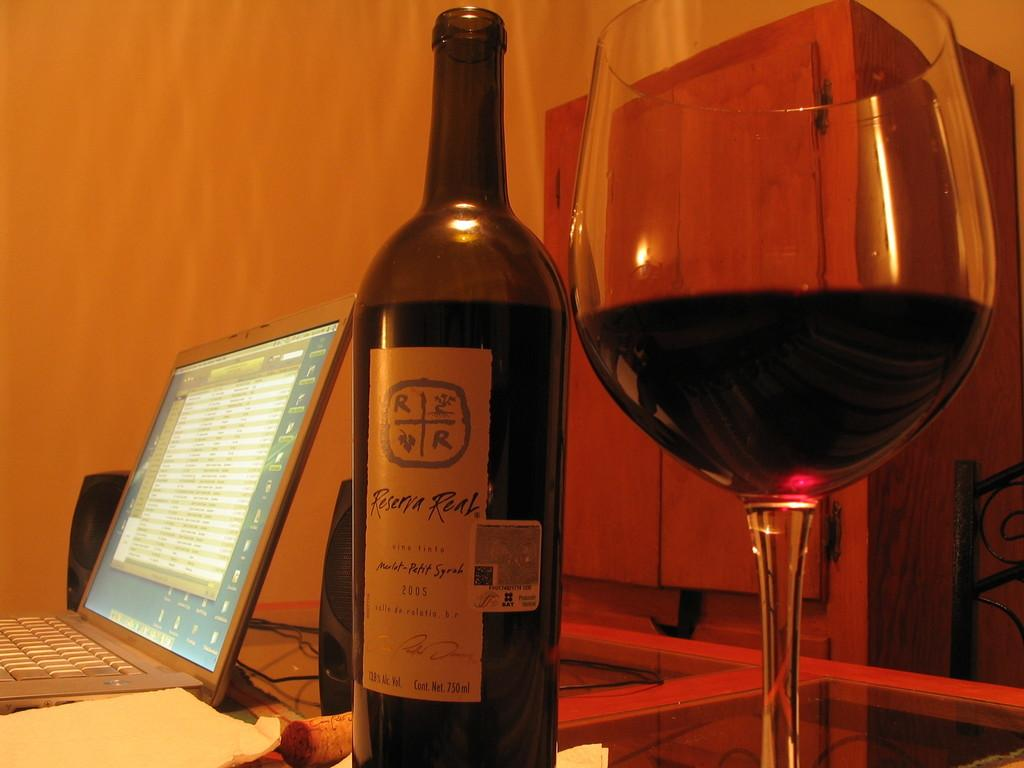Provide a one-sentence caption for the provided image. A bottle of Reserva Real sits on a glass table next to a half full glass. 